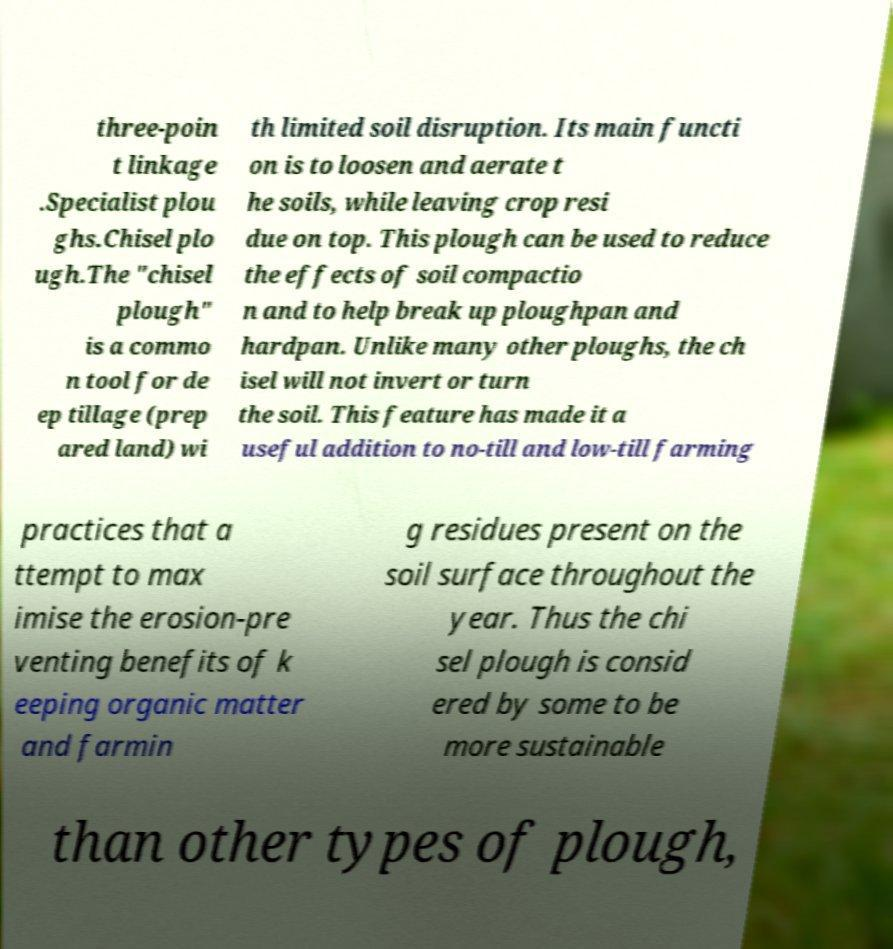Can you read and provide the text displayed in the image?This photo seems to have some interesting text. Can you extract and type it out for me? three-poin t linkage .Specialist plou ghs.Chisel plo ugh.The "chisel plough" is a commo n tool for de ep tillage (prep ared land) wi th limited soil disruption. Its main functi on is to loosen and aerate t he soils, while leaving crop resi due on top. This plough can be used to reduce the effects of soil compactio n and to help break up ploughpan and hardpan. Unlike many other ploughs, the ch isel will not invert or turn the soil. This feature has made it a useful addition to no-till and low-till farming practices that a ttempt to max imise the erosion-pre venting benefits of k eeping organic matter and farmin g residues present on the soil surface throughout the year. Thus the chi sel plough is consid ered by some to be more sustainable than other types of plough, 